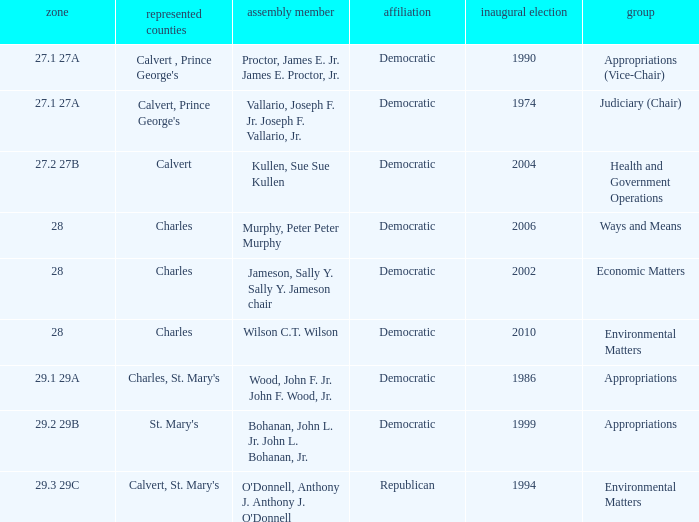Help me parse the entirety of this table. {'header': ['zone', 'represented counties', 'assembly member', 'affiliation', 'inaugural election', 'group'], 'rows': [['27.1 27A', "Calvert , Prince George's", 'Proctor, James E. Jr. James E. Proctor, Jr.', 'Democratic', '1990', 'Appropriations (Vice-Chair)'], ['27.1 27A', "Calvert, Prince George's", 'Vallario, Joseph F. Jr. Joseph F. Vallario, Jr.', 'Democratic', '1974', 'Judiciary (Chair)'], ['27.2 27B', 'Calvert', 'Kullen, Sue Sue Kullen', 'Democratic', '2004', 'Health and Government Operations'], ['28', 'Charles', 'Murphy, Peter Peter Murphy', 'Democratic', '2006', 'Ways and Means'], ['28', 'Charles', 'Jameson, Sally Y. Sally Y. Jameson chair', 'Democratic', '2002', 'Economic Matters'], ['28', 'Charles', 'Wilson C.T. Wilson', 'Democratic', '2010', 'Environmental Matters'], ['29.1 29A', "Charles, St. Mary's", 'Wood, John F. Jr. John F. Wood, Jr.', 'Democratic', '1986', 'Appropriations'], ['29.2 29B', "St. Mary's", 'Bohanan, John L. Jr. John L. Bohanan, Jr.', 'Democratic', '1999', 'Appropriations'], ['29.3 29C', "Calvert, St. Mary's", "O'Donnell, Anthony J. Anthony J. O'Donnell", 'Republican', '1994', 'Environmental Matters']]} When first elected was 2006, who was the delegate? Murphy, Peter Peter Murphy. 